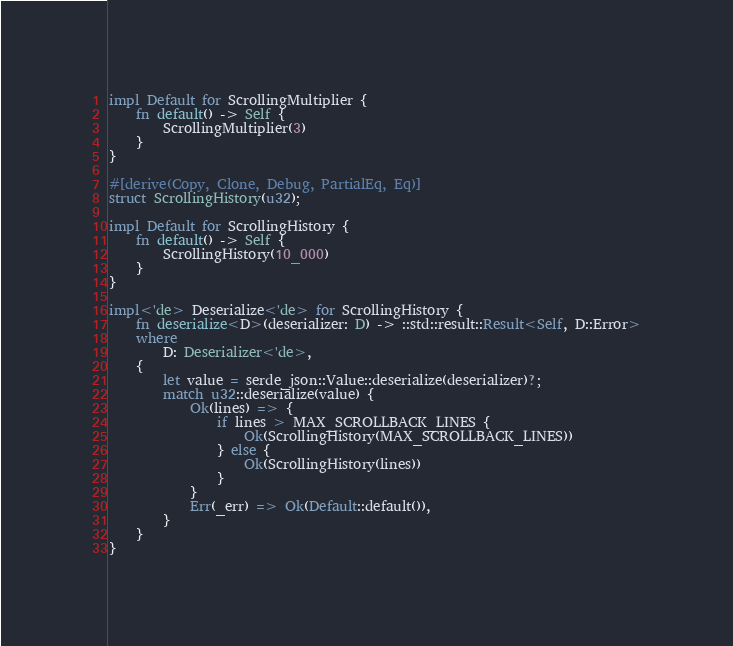<code> <loc_0><loc_0><loc_500><loc_500><_Rust_>
impl Default for ScrollingMultiplier {
    fn default() -> Self {
        ScrollingMultiplier(3)
    }
}

#[derive(Copy, Clone, Debug, PartialEq, Eq)]
struct ScrollingHistory(u32);

impl Default for ScrollingHistory {
    fn default() -> Self {
        ScrollingHistory(10_000)
    }
}

impl<'de> Deserialize<'de> for ScrollingHistory {
    fn deserialize<D>(deserializer: D) -> ::std::result::Result<Self, D::Error>
    where
        D: Deserializer<'de>,
    {
        let value = serde_json::Value::deserialize(deserializer)?;
        match u32::deserialize(value) {
            Ok(lines) => {
                if lines > MAX_SCROLLBACK_LINES {
                    Ok(ScrollingHistory(MAX_SCROLLBACK_LINES))
                } else {
                    Ok(ScrollingHistory(lines))
                }
            }
            Err(_err) => Ok(Default::default()),
        }
    }
}
</code> 